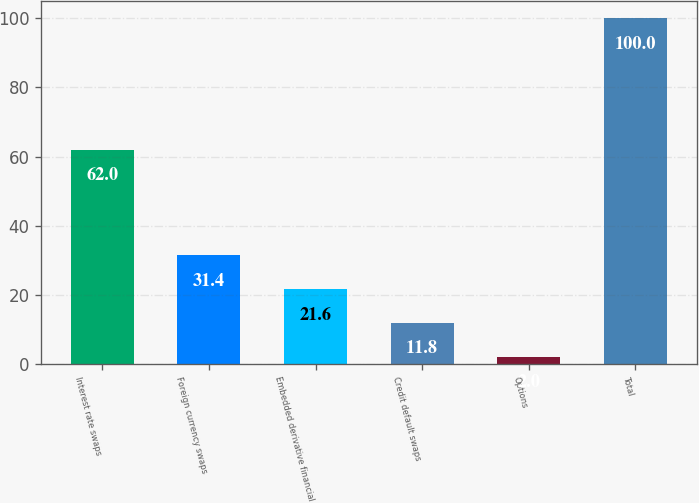Convert chart to OTSL. <chart><loc_0><loc_0><loc_500><loc_500><bar_chart><fcel>Interest rate swaps<fcel>Foreign currency swaps<fcel>Embedded derivative financial<fcel>Credit default swaps<fcel>Options<fcel>Total<nl><fcel>62<fcel>31.4<fcel>21.6<fcel>11.8<fcel>2<fcel>100<nl></chart> 